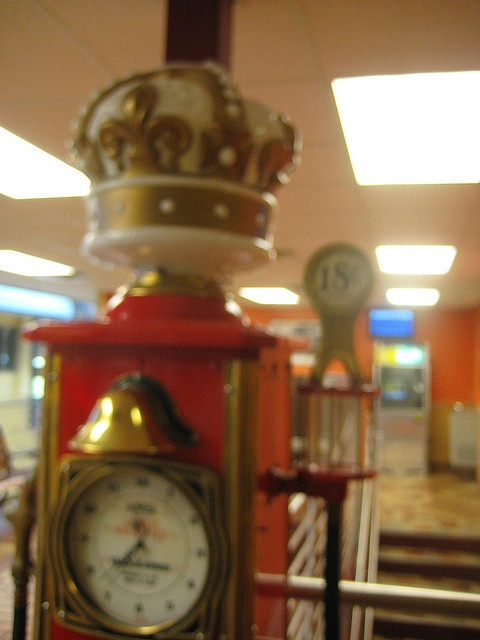Describe the objects in this image and their specific colors. I can see clock in gray, olive, and black tones and clock in gray and olive tones in this image. 